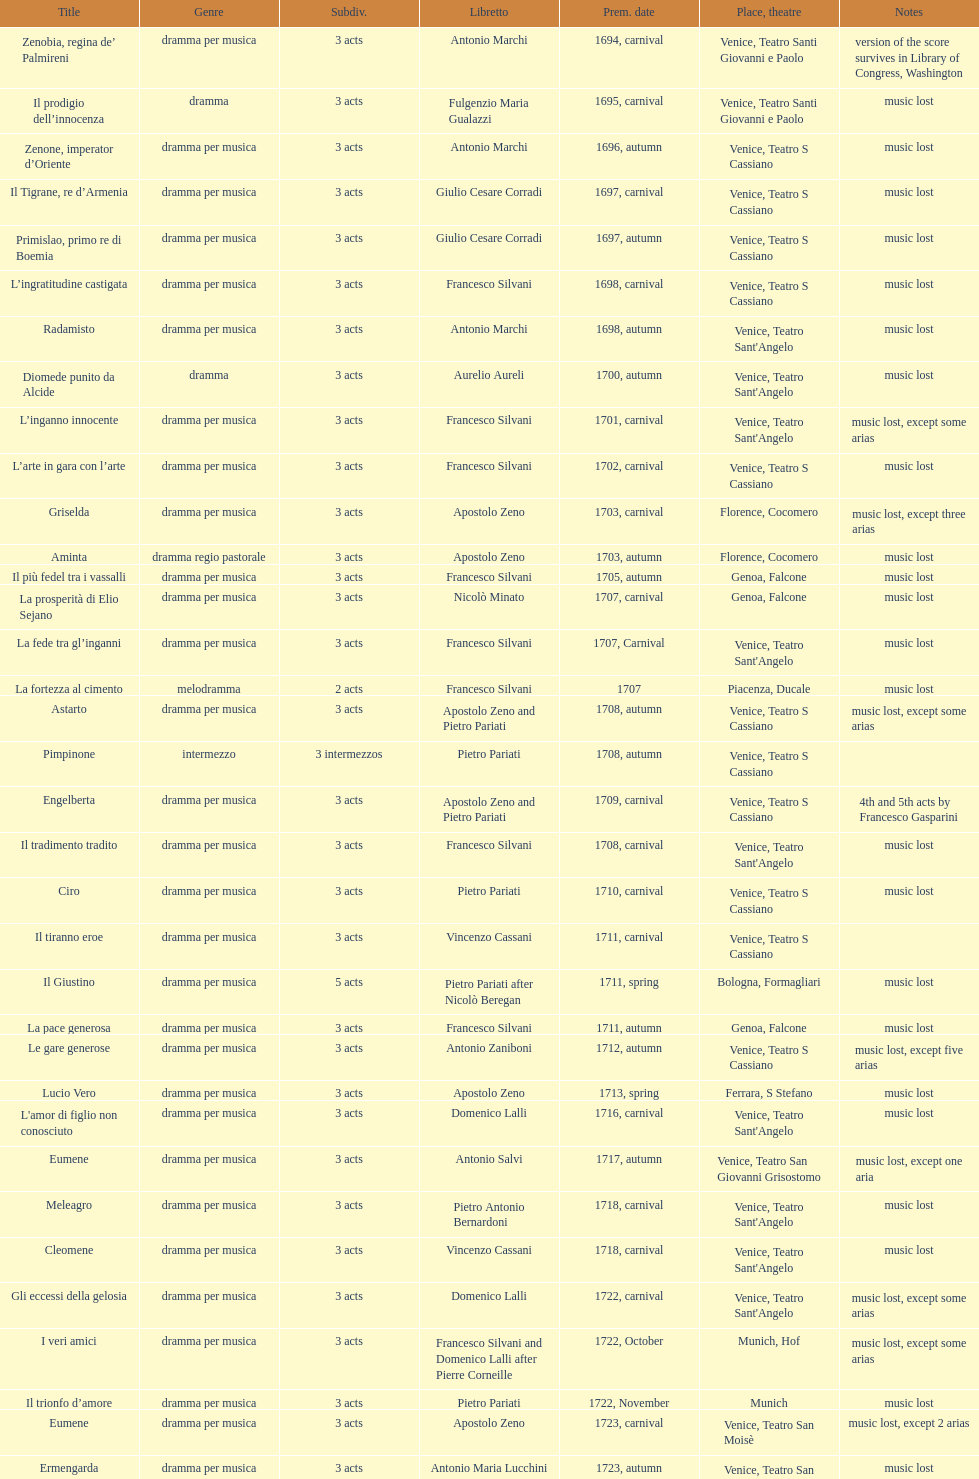How many were released after zenone, imperator d'oriente? 52. 